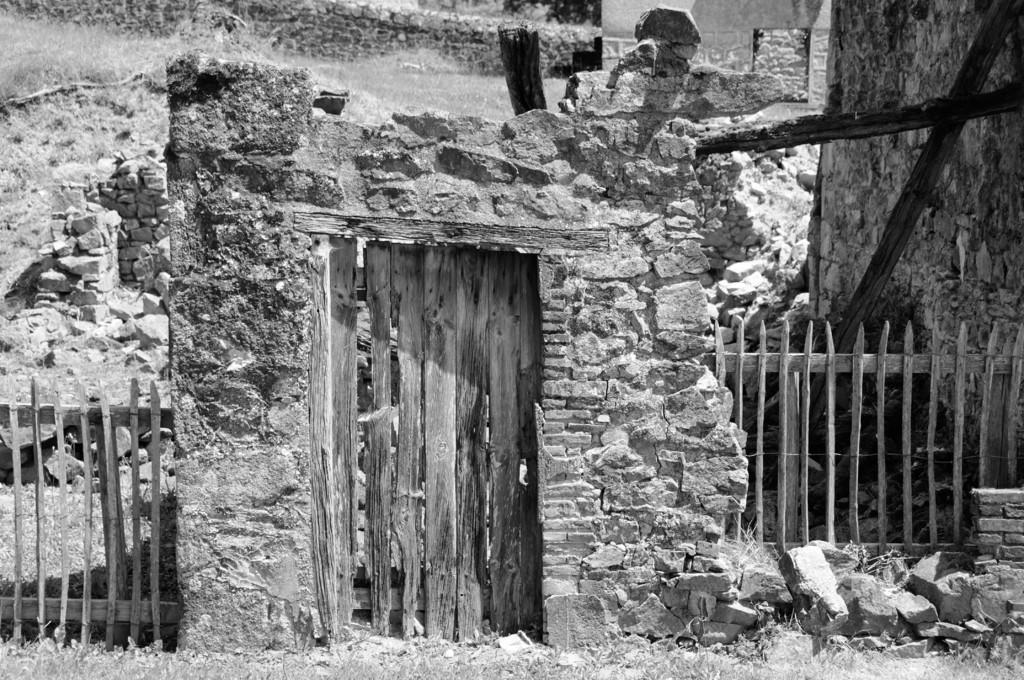What is the main structure in the image? There is a monument in the image. What type of barrier can be seen in the image? There is a wooden fence in the image. What type of terrain is visible in the image? There is a grassy land in the image. What type of furniture is present in the image? There is no furniture present in the image. Can you describe the relationship between the two brothers in the image? There are no people, let alone brothers, present in the image. 